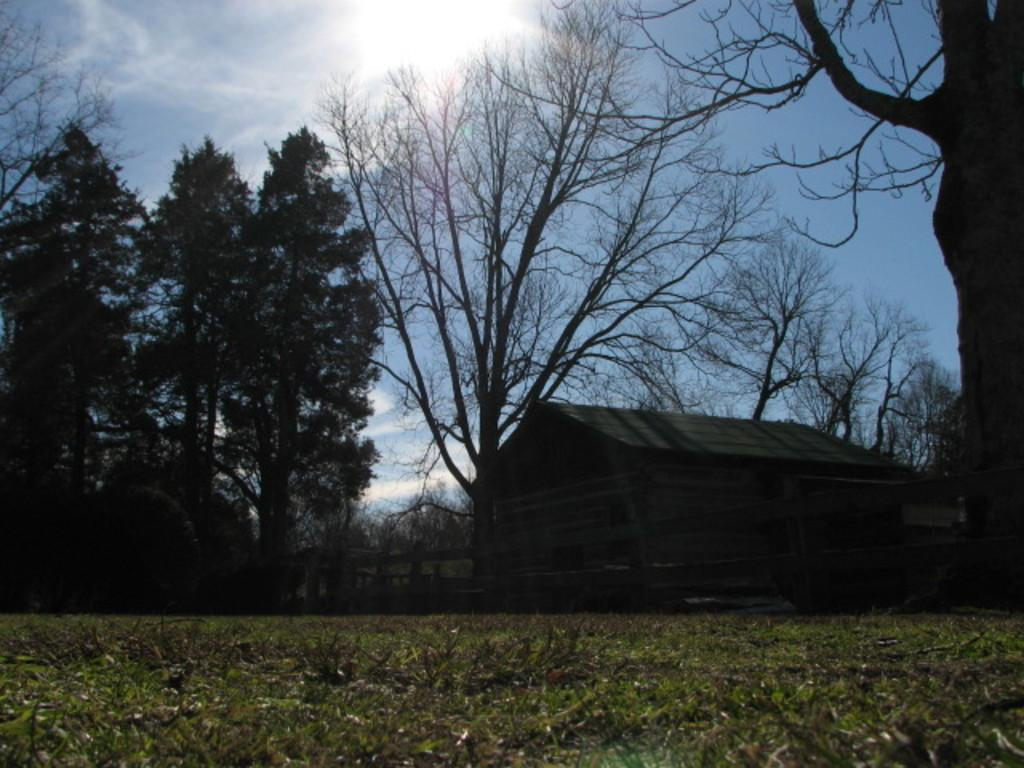What type of vegetation can be seen in the image? There are trees with branches and leaves in the image. What type of structure is visible in the image? There appears to be a house in the image. What type of barrier is present in the image? A wooden fence is visible in the image. What type of ground cover is present in the image? There is grass in the image. What can be seen in the sky in the image? Clouds are present in the sky in the image. What type of wool is being used to represent the clouds in the image? There is no wool present in the image, and the clouds are not represented by any material. 